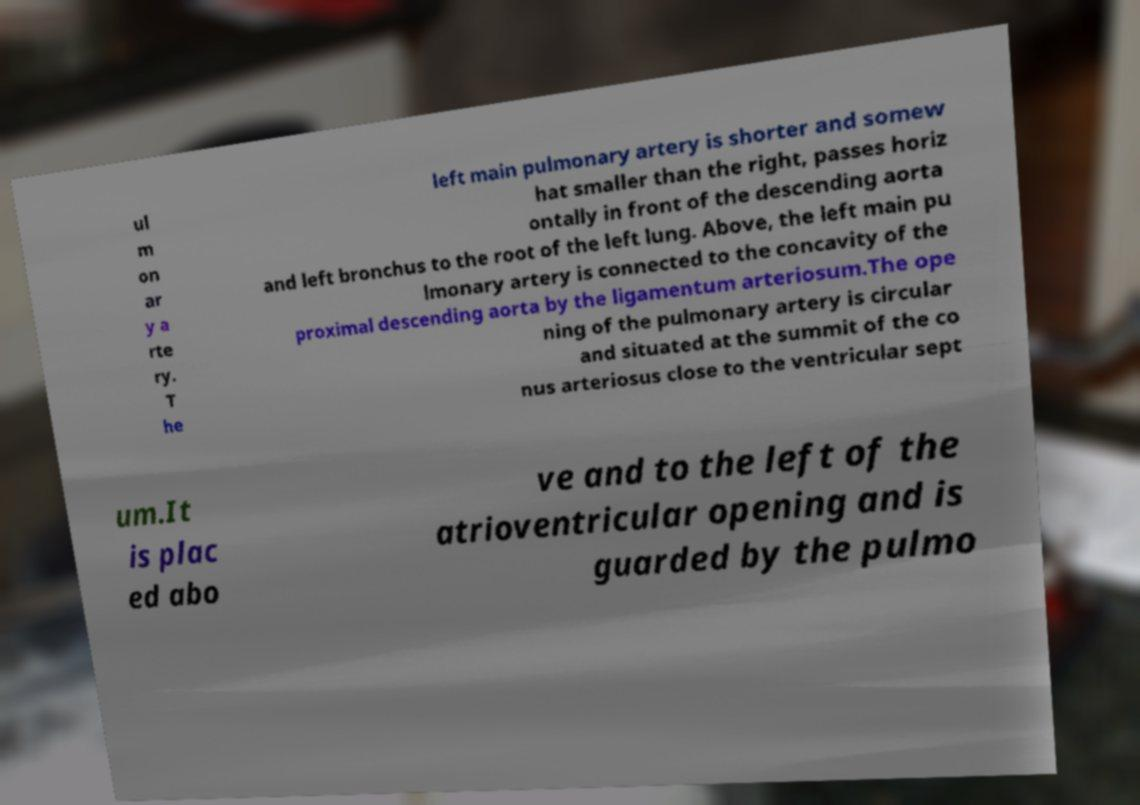What messages or text are displayed in this image? I need them in a readable, typed format. ul m on ar y a rte ry. T he left main pulmonary artery is shorter and somew hat smaller than the right, passes horiz ontally in front of the descending aorta and left bronchus to the root of the left lung. Above, the left main pu lmonary artery is connected to the concavity of the proximal descending aorta by the ligamentum arteriosum.The ope ning of the pulmonary artery is circular and situated at the summit of the co nus arteriosus close to the ventricular sept um.It is plac ed abo ve and to the left of the atrioventricular opening and is guarded by the pulmo 